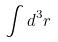<formula> <loc_0><loc_0><loc_500><loc_500>\int d ^ { 3 } r</formula> 